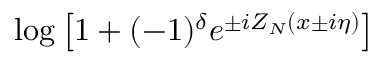<formula> <loc_0><loc_0><loc_500><loc_500>\log \left [ 1 + ( - 1 ) ^ { \delta } e ^ { \pm i Z _ { N } ( x \pm i \eta ) } \right ]</formula> 